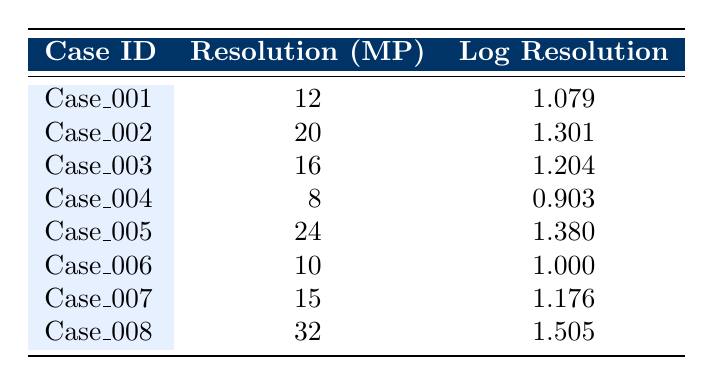What is the image resolution (in megapixels) for Case_003? The table indicates that the resolution for Case_003 is listed directly under the corresponding case ID. It shows 16 megapixels.
Answer: 16 Which case has the highest image resolution? By examining the resolution values, I see that Case_008 has the highest resolution with 32 megapixels.
Answer: Case_008 What is the average image resolution across all cases? To find the average, first sum the resolutions: 12 + 20 + 16 + 8 + 24 + 10 + 15 + 32 =  137. There are 8 cases, so the average is 137/8 = 17.125.
Answer: 17.125 Is the log resolution for Case_006 greater than 1? The log resolution for Case_006 is listed as 1.000, which is not greater than 1. Thus, the answer is false.
Answer: No How many cases have an image resolution below 15 megapixels? By reviewing the table, Case_001 (12 MP), Case_004 (8 MP), and Case_006 (10 MP) have resolutions below 15. This gives us 3 cases.
Answer: 3 What is the difference in image resolution between Case_005 and Case_002? Case_005 has a resolution of 24 MP, while Case_002 has 20 MP. The difference is calculated as 24 - 20 = 4.
Answer: 4 Which case has a log resolution that is the closest to 1? From the log resolution values, Case_006 (1.000) matches exactly 1, making it the closest.
Answer: Case_006 Which case shows the smallest difference in log resolution compared to the case with the highest log resolution? The highest log resolution is for Case_008 at 1.505. The next highest is Case_005 at 1.380, which has a difference of 1.505 - 1.380 = 0.125. This is the smallest difference in log resolution in the provided cases.
Answer: Case_005 